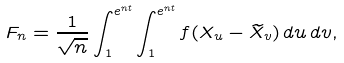Convert formula to latex. <formula><loc_0><loc_0><loc_500><loc_500>F _ { n } = \frac { 1 } { \sqrt { n } } \int ^ { e ^ { n t } } _ { 1 } \int ^ { e ^ { n t } } _ { 1 } f ( X _ { u } - \widetilde { X } _ { v } ) \, d u \, d v ,</formula> 